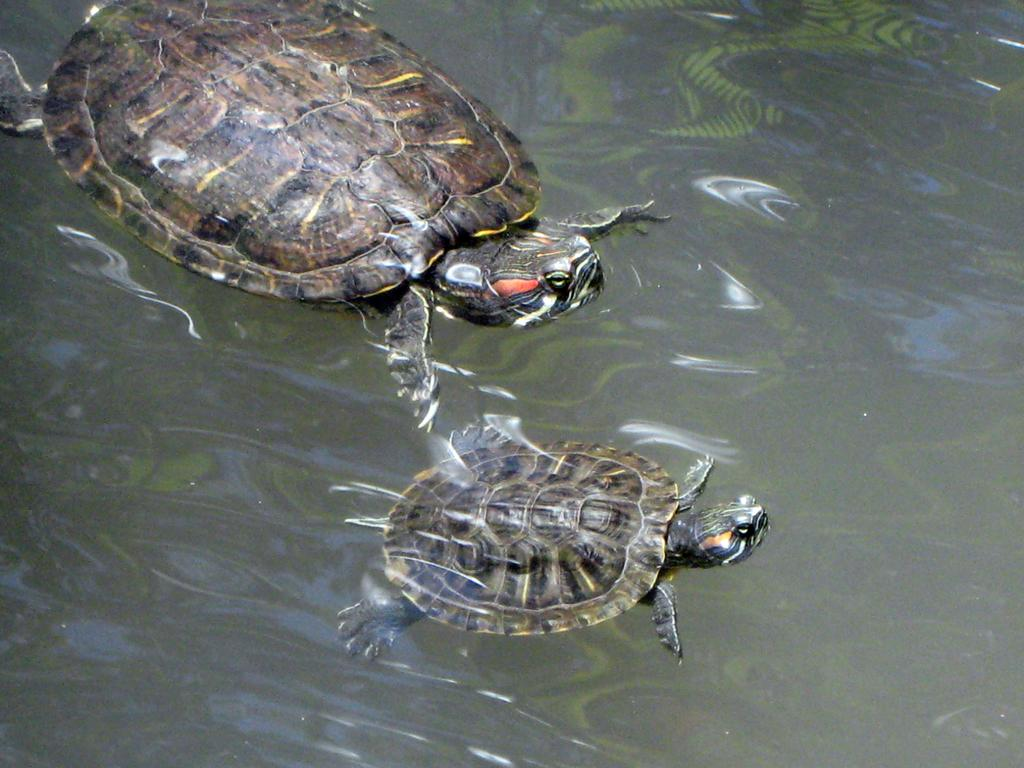What animals are present in the image? There are two tortoises in the image. Where are the tortoises located? The tortoises are in water. What type of beast is depicted on the page in the image? There is no page or beast present in the image; it features two tortoises in water. 